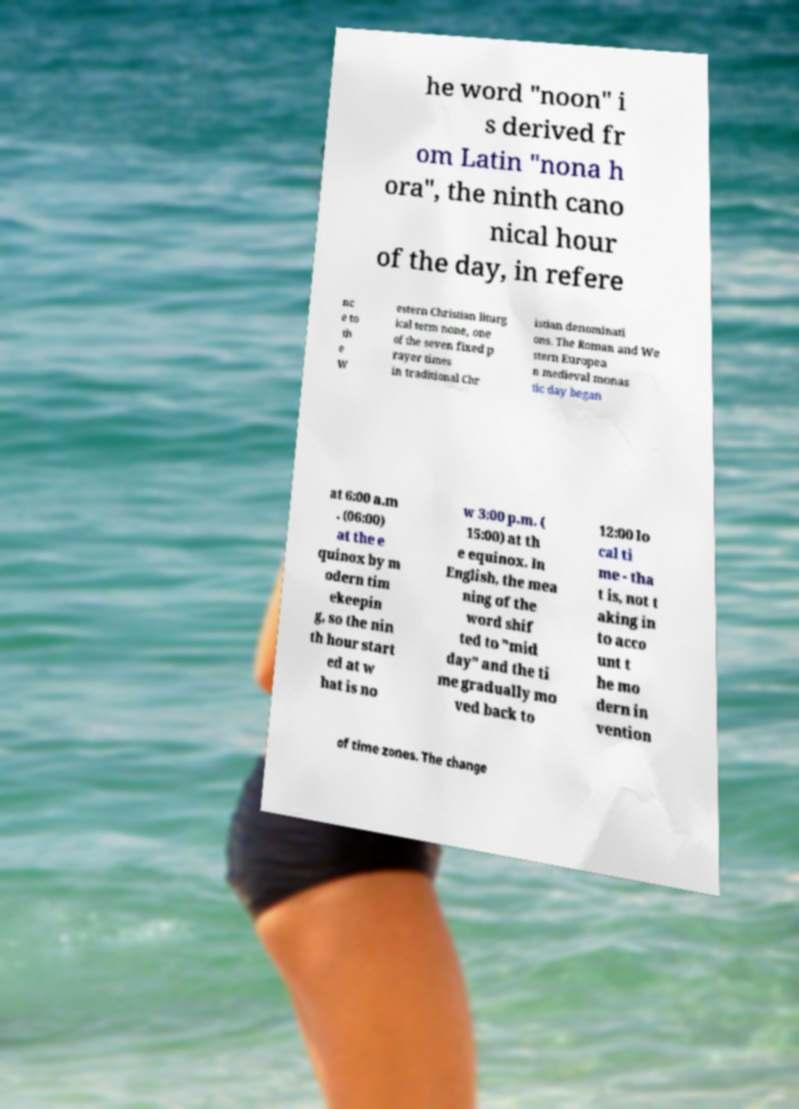Could you assist in decoding the text presented in this image and type it out clearly? he word "noon" i s derived fr om Latin "nona h ora", the ninth cano nical hour of the day, in refere nc e to th e W estern Christian liturg ical term none, one of the seven fixed p rayer times in traditional Chr istian denominati ons. The Roman and We stern Europea n medieval monas tic day began at 6:00 a.m . (06:00) at the e quinox by m odern tim ekeepin g, so the nin th hour start ed at w hat is no w 3:00 p.m. ( 15:00) at th e equinox. In English, the mea ning of the word shif ted to "mid day" and the ti me gradually mo ved back to 12:00 lo cal ti me - tha t is, not t aking in to acco unt t he mo dern in vention of time zones. The change 